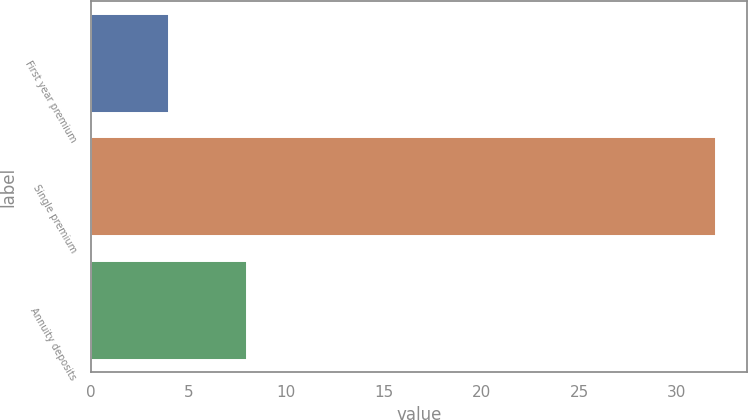Convert chart. <chart><loc_0><loc_0><loc_500><loc_500><bar_chart><fcel>First year premium<fcel>Single premium<fcel>Annuity deposits<nl><fcel>4<fcel>32<fcel>8<nl></chart> 